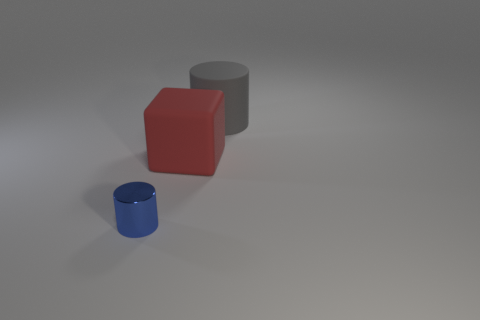Add 2 yellow shiny cubes. How many objects exist? 5 Subtract all blue cylinders. How many cylinders are left? 1 Subtract all blocks. How many objects are left? 2 Subtract all gray cylinders. Subtract all blue cubes. How many cylinders are left? 1 Subtract all green balls. How many yellow cylinders are left? 0 Subtract all small cyan matte cubes. Subtract all large gray rubber cylinders. How many objects are left? 2 Add 2 big gray objects. How many big gray objects are left? 3 Add 1 rubber cylinders. How many rubber cylinders exist? 2 Subtract 0 purple cubes. How many objects are left? 3 